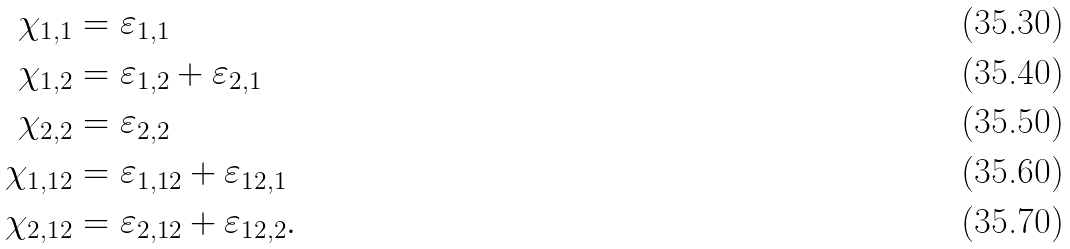<formula> <loc_0><loc_0><loc_500><loc_500>\chi _ { 1 , 1 } & = \varepsilon _ { 1 , 1 } \\ \chi _ { 1 , 2 } & = \varepsilon _ { 1 , 2 } + \varepsilon _ { 2 , 1 } \\ \chi _ { 2 , 2 } & = \varepsilon _ { 2 , 2 } \\ \chi _ { 1 , 1 2 } & = \varepsilon _ { 1 , 1 2 } + \varepsilon _ { 1 2 , 1 } \\ \chi _ { 2 , 1 2 } & = \varepsilon _ { 2 , 1 2 } + \varepsilon _ { 1 2 , 2 } .</formula> 